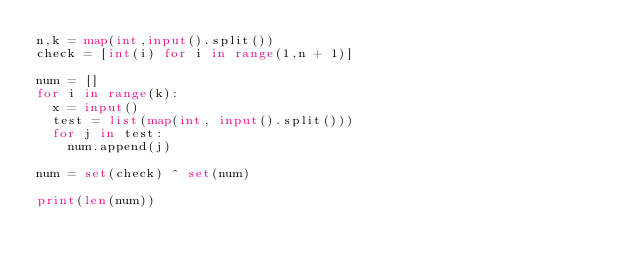Convert code to text. <code><loc_0><loc_0><loc_500><loc_500><_Python_>n,k = map(int,input().split())
check = [int(i) for i in range(1,n + 1)]

num = []
for i in range(k):
  x = input()
  test = list(map(int, input().split()))
  for j in test:
    num.append(j)

num = set(check) ^ set(num)

print(len(num))
</code> 